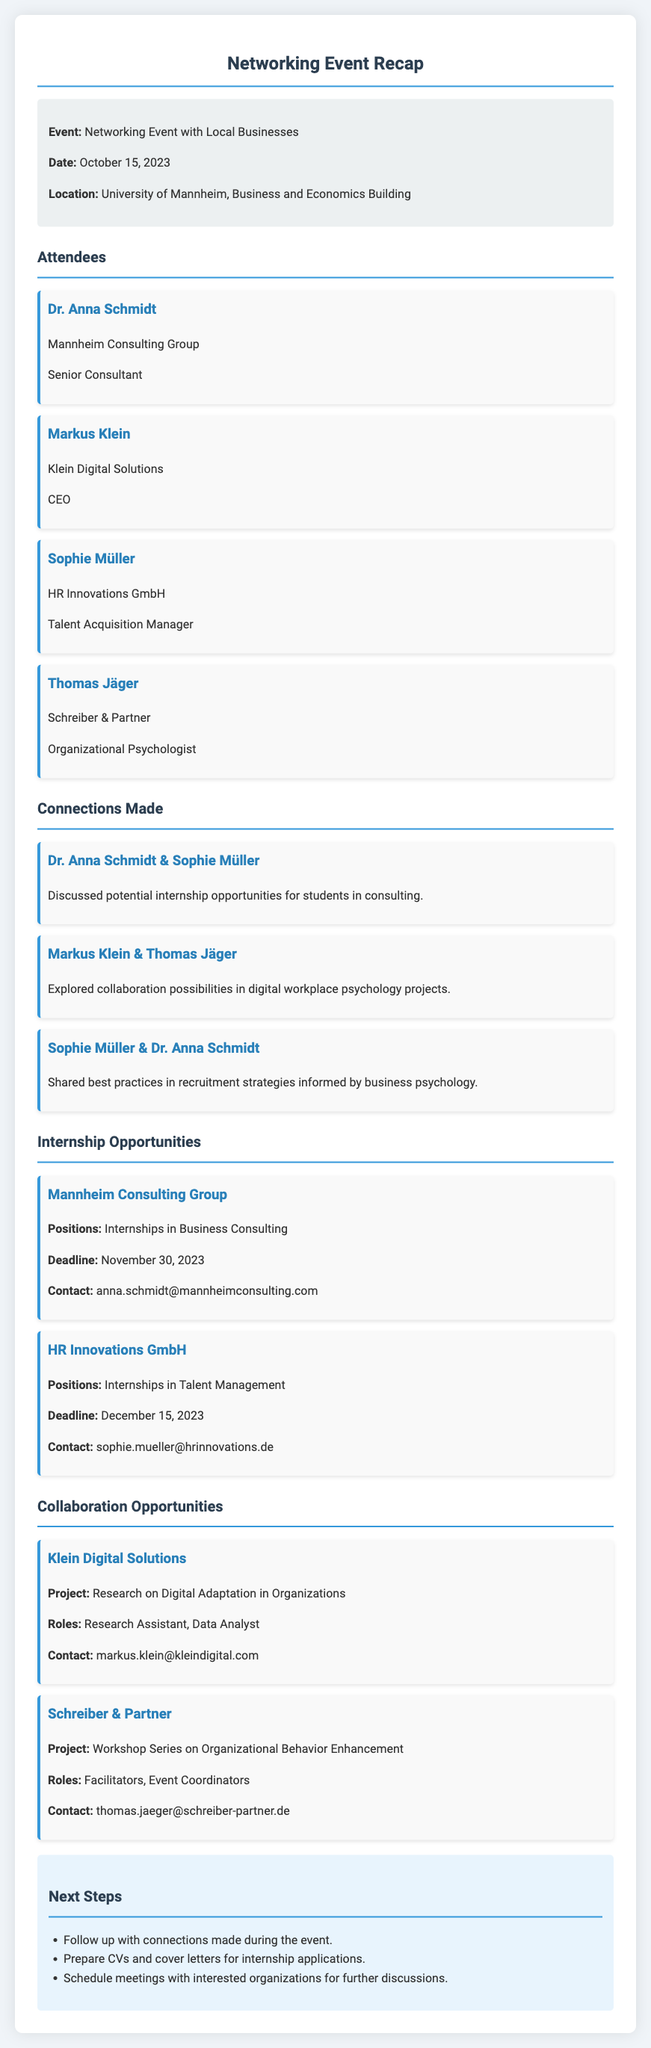what was the date of the networking event? The date of the networking event is specified in the document under event details.
Answer: October 15, 2023 who is the CEO of Klein Digital Solutions? The document lists attendees, including their titles and organizations, where the CEO's name is provided.
Answer: Markus Klein which organization is offering internships in Talent Management? The section on internship opportunities specifies which companies are offering internships and their respective focus areas.
Answer: HR Innovations GmbH how many attendees were listed in the document? The attendees section includes a specific number of individuals listed as participants in the event.
Answer: 4 what is the deadline for applying to internships at Mannheim Consulting Group? The document provides specific deadlines for internship applications within the internship opportunities section.
Answer: November 30, 2023 which company is focusing on research regarding digital adaptation in organizations? The collaboration opportunities section indicates specific projects along with their corresponding organizations.
Answer: Klein Digital Solutions what are the next steps after the event according to the document? The document contains a 'Next Steps' section that outlines actions to be taken following the event.
Answer: Follow up with connections made during the event who can be contacted for internship positions at HR Innovations GmbH? The internship opportunities section includes contact information for the specific internship programs offered by various companies.
Answer: sophie.mueller@hrinnovations.de 